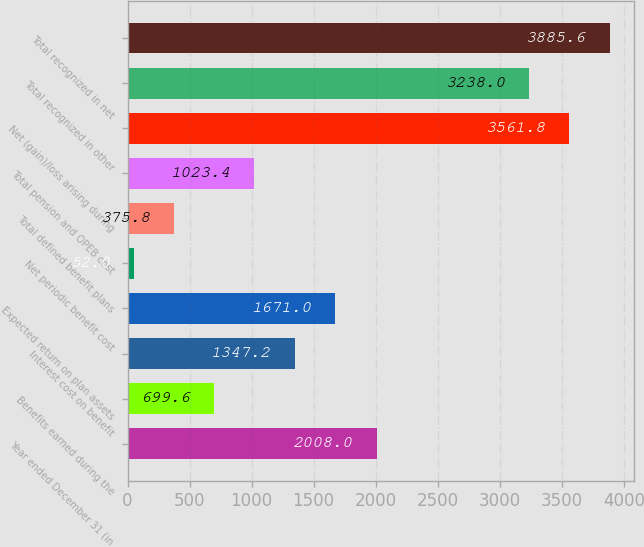<chart> <loc_0><loc_0><loc_500><loc_500><bar_chart><fcel>Year ended December 31 (in<fcel>Benefits earned during the<fcel>Interest cost on benefit<fcel>Expected return on plan assets<fcel>Net periodic benefit cost<fcel>Total defined benefit plans<fcel>Total pension and OPEB cost<fcel>Net (gain)/loss arising during<fcel>Total recognized in other<fcel>Total recognized in net<nl><fcel>2008<fcel>699.6<fcel>1347.2<fcel>1671<fcel>52<fcel>375.8<fcel>1023.4<fcel>3561.8<fcel>3238<fcel>3885.6<nl></chart> 